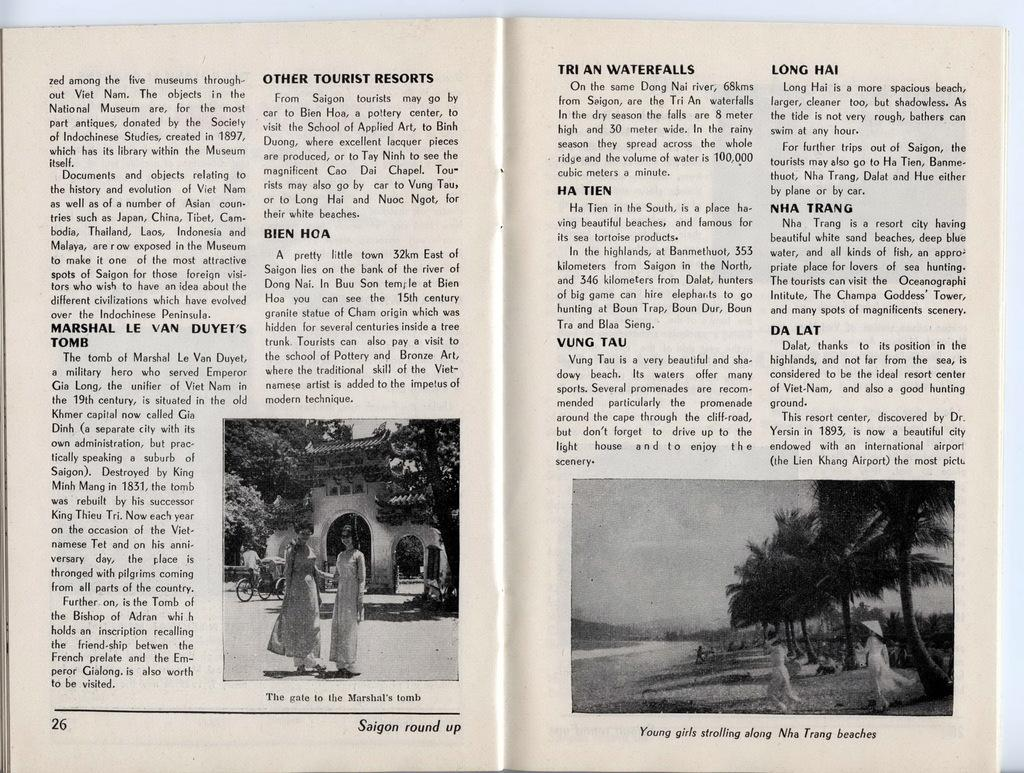What is present in the image that contains both text and images? There is a poster in the image that contains text and images. Can you describe the content of the poster? The poster contains text and images, but the specific content cannot be determined from the provided facts. How many boys are riding the zebra in the image? There is no boy or zebra present in the image; it only contains a poster with text and images. 